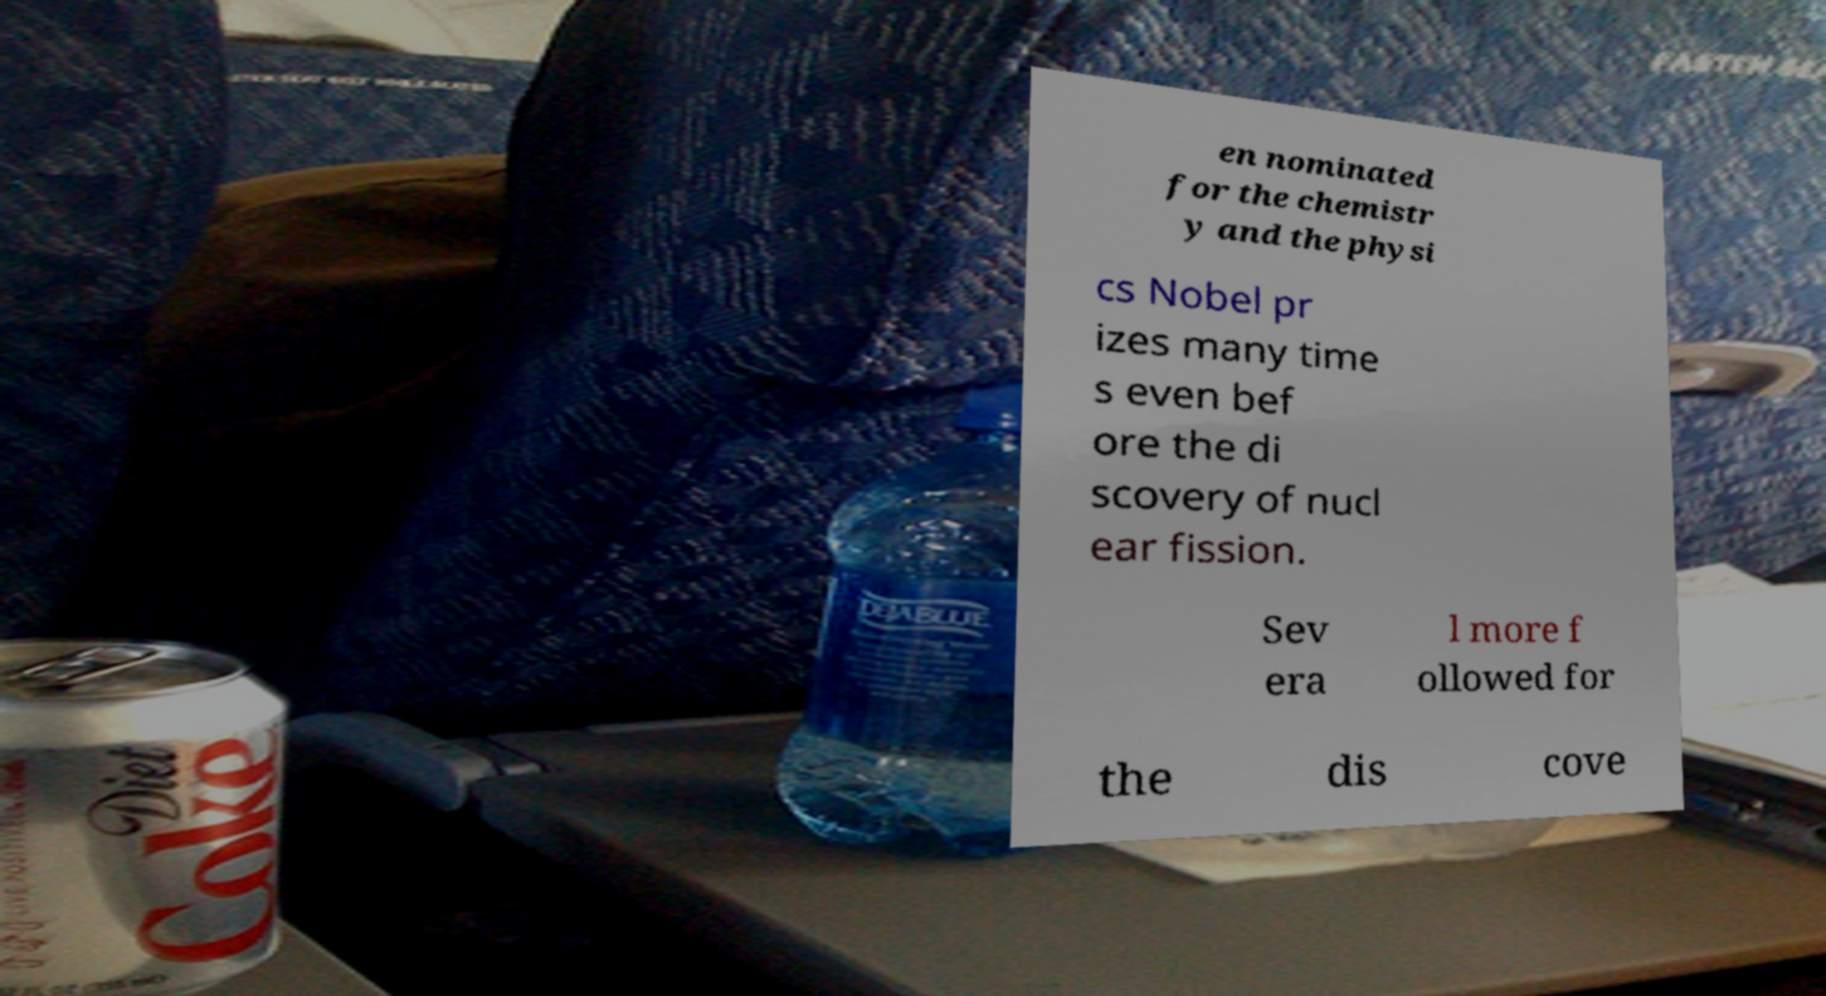Could you assist in decoding the text presented in this image and type it out clearly? en nominated for the chemistr y and the physi cs Nobel pr izes many time s even bef ore the di scovery of nucl ear fission. Sev era l more f ollowed for the dis cove 